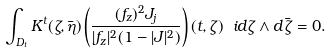Convert formula to latex. <formula><loc_0><loc_0><loc_500><loc_500>\int _ { D _ { t } } K ^ { t } ( \zeta , \bar { \eta } ) \left ( \frac { ( f _ { z } ) ^ { 2 } J _ { j } } { | f _ { z } | ^ { 2 } ( 1 - | J | ^ { 2 } ) } \right ) ( t , \zeta ) \ i d \zeta \wedge d \bar { \zeta } = 0 .</formula> 